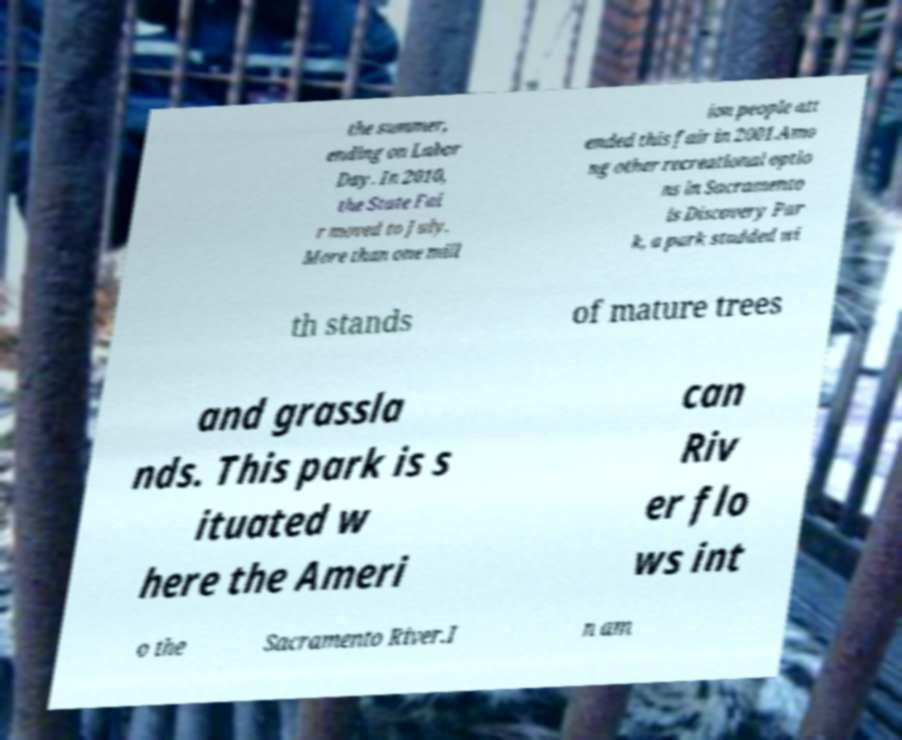There's text embedded in this image that I need extracted. Can you transcribe it verbatim? the summer, ending on Labor Day. In 2010, the State Fai r moved to July. More than one mill ion people att ended this fair in 2001.Amo ng other recreational optio ns in Sacramento is Discovery Par k, a park studded wi th stands of mature trees and grassla nds. This park is s ituated w here the Ameri can Riv er flo ws int o the Sacramento River.I n am 